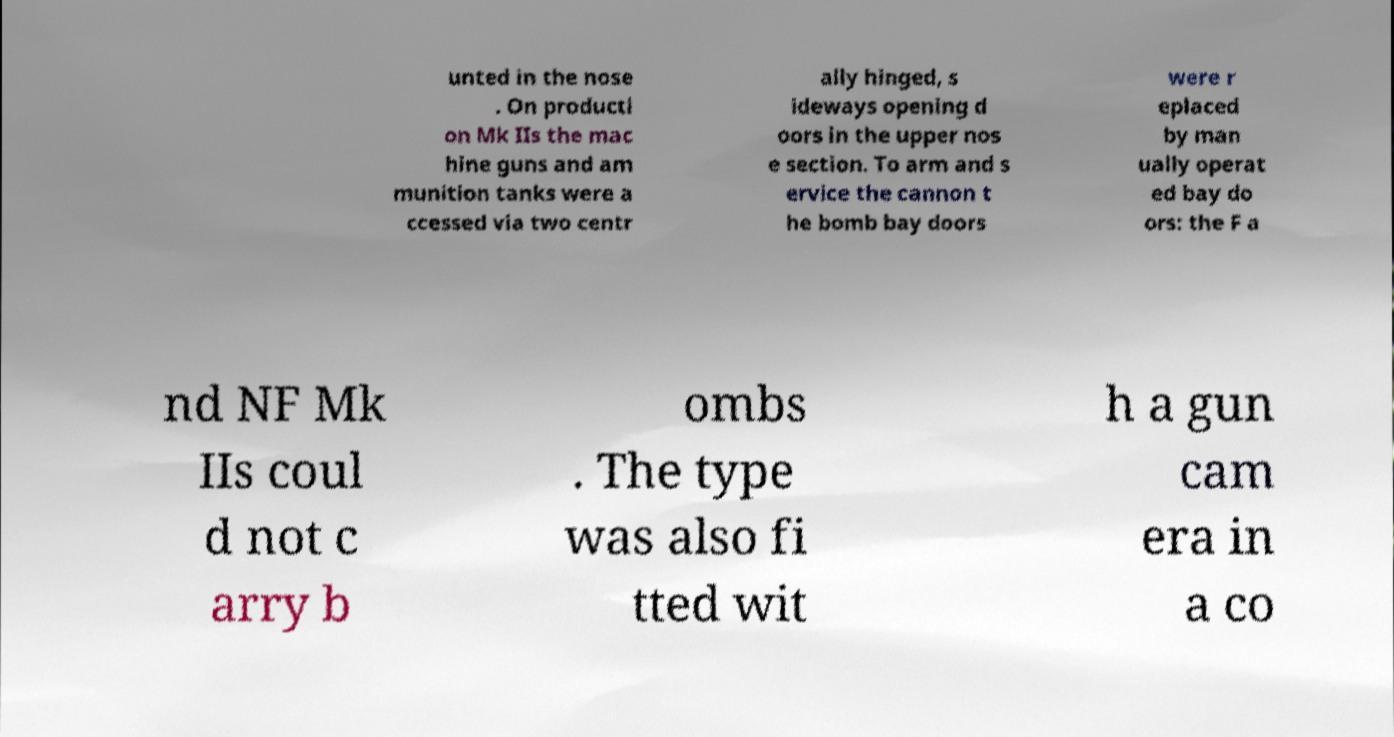Could you extract and type out the text from this image? unted in the nose . On producti on Mk IIs the mac hine guns and am munition tanks were a ccessed via two centr ally hinged, s ideways opening d oors in the upper nos e section. To arm and s ervice the cannon t he bomb bay doors were r eplaced by man ually operat ed bay do ors: the F a nd NF Mk IIs coul d not c arry b ombs . The type was also fi tted wit h a gun cam era in a co 